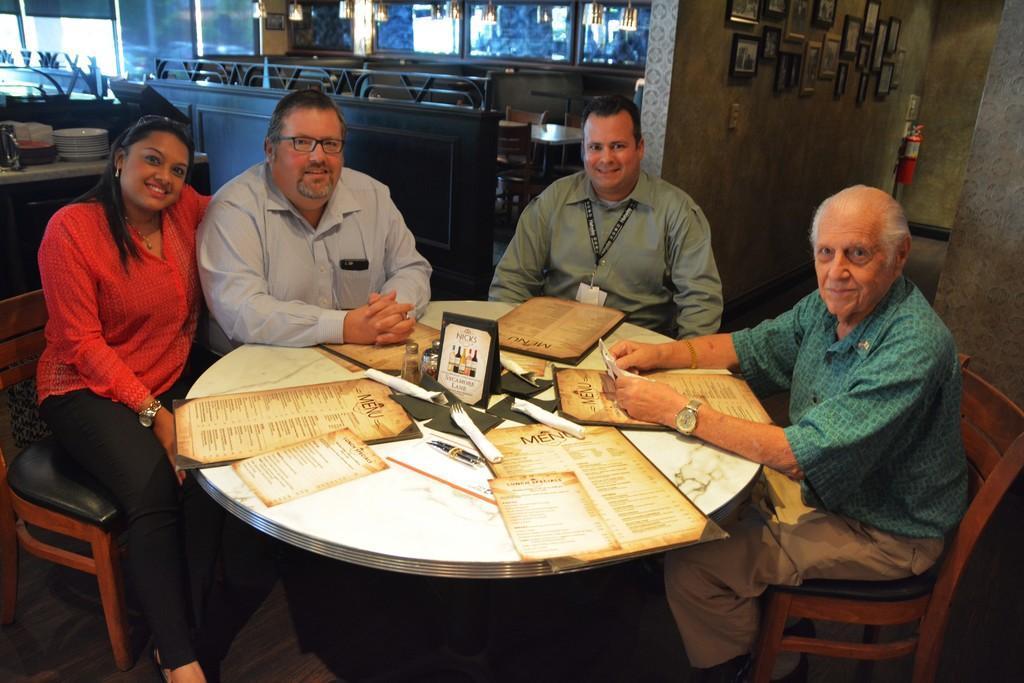Please provide a concise description of this image. In this picture we can see three men and one woman sitting on chair and they are smiling and in front of them on table we have card, bottles, papers and in the background we can see plates, fence, wall with frames, fire extinguisher. 